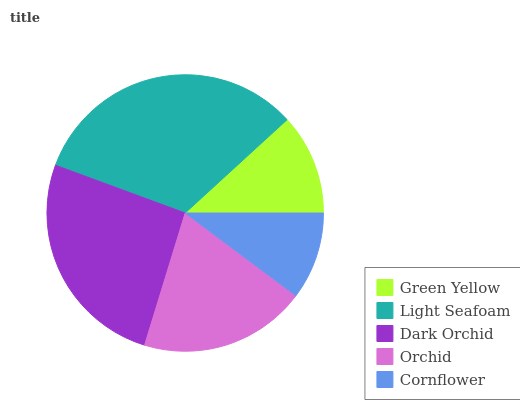Is Cornflower the minimum?
Answer yes or no. Yes. Is Light Seafoam the maximum?
Answer yes or no. Yes. Is Dark Orchid the minimum?
Answer yes or no. No. Is Dark Orchid the maximum?
Answer yes or no. No. Is Light Seafoam greater than Dark Orchid?
Answer yes or no. Yes. Is Dark Orchid less than Light Seafoam?
Answer yes or no. Yes. Is Dark Orchid greater than Light Seafoam?
Answer yes or no. No. Is Light Seafoam less than Dark Orchid?
Answer yes or no. No. Is Orchid the high median?
Answer yes or no. Yes. Is Orchid the low median?
Answer yes or no. Yes. Is Cornflower the high median?
Answer yes or no. No. Is Green Yellow the low median?
Answer yes or no. No. 